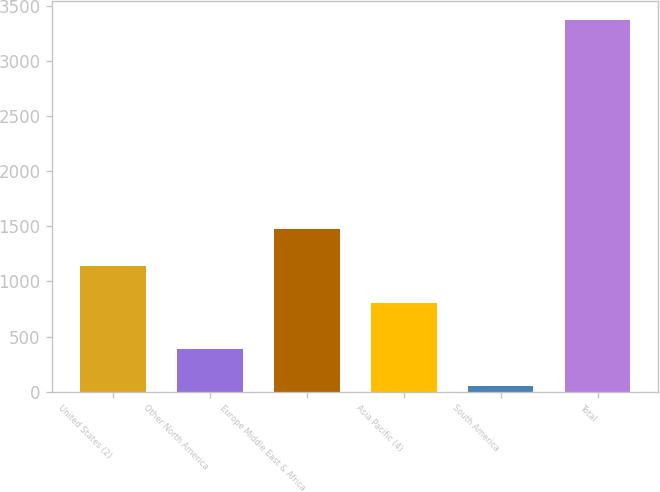<chart> <loc_0><loc_0><loc_500><loc_500><bar_chart><fcel>United States (2)<fcel>Other North America<fcel>Europe Middle East & Africa<fcel>Asia Pacific (4)<fcel>South America<fcel>Total<nl><fcel>1141.3<fcel>386.3<fcel>1473.6<fcel>809<fcel>54<fcel>3377<nl></chart> 